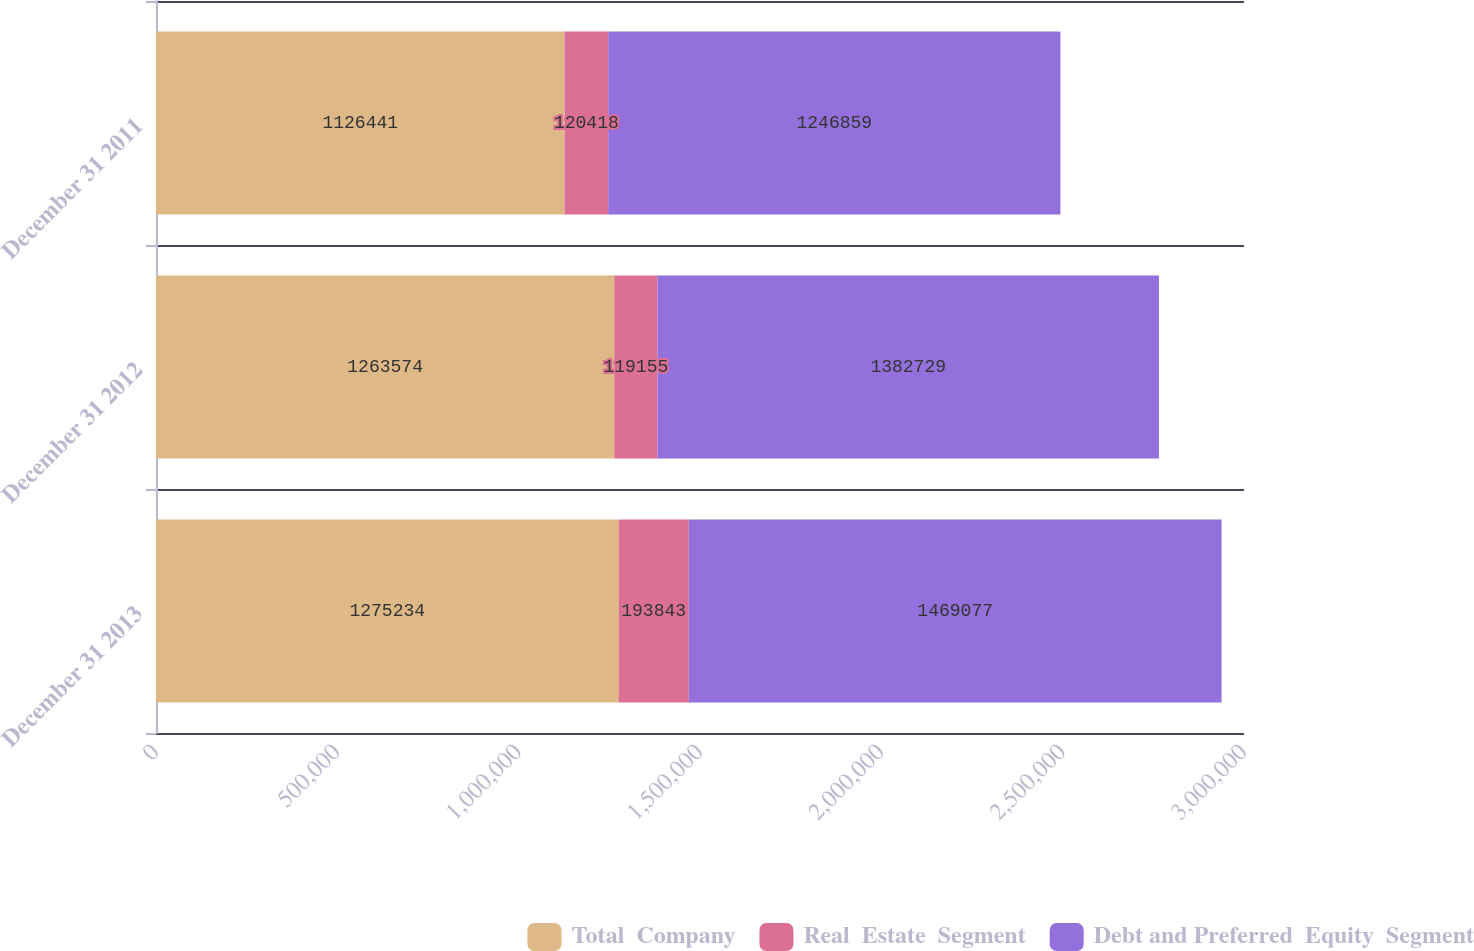<chart> <loc_0><loc_0><loc_500><loc_500><stacked_bar_chart><ecel><fcel>December 31 2013<fcel>December 31 2012<fcel>December 31 2011<nl><fcel>Total  Company<fcel>1.27523e+06<fcel>1.26357e+06<fcel>1.12644e+06<nl><fcel>Real  Estate  Segment<fcel>193843<fcel>119155<fcel>120418<nl><fcel>Debt and Preferred  Equity  Segment<fcel>1.46908e+06<fcel>1.38273e+06<fcel>1.24686e+06<nl></chart> 